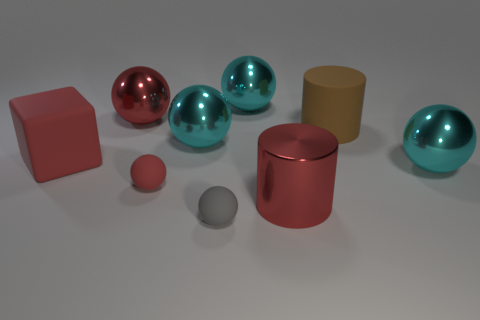Are the objects giving off any reflections? Yes, some of the objects, particularly the spheres, exhibit reflective surfaces that mirror the environment and display high glossiness, contrasting with the matte surfaces of other objects. Which object stands out the most to you? The large teal sphere stands out due to its vibrant color and shiny surface, drawing attention amidst the other objects. 